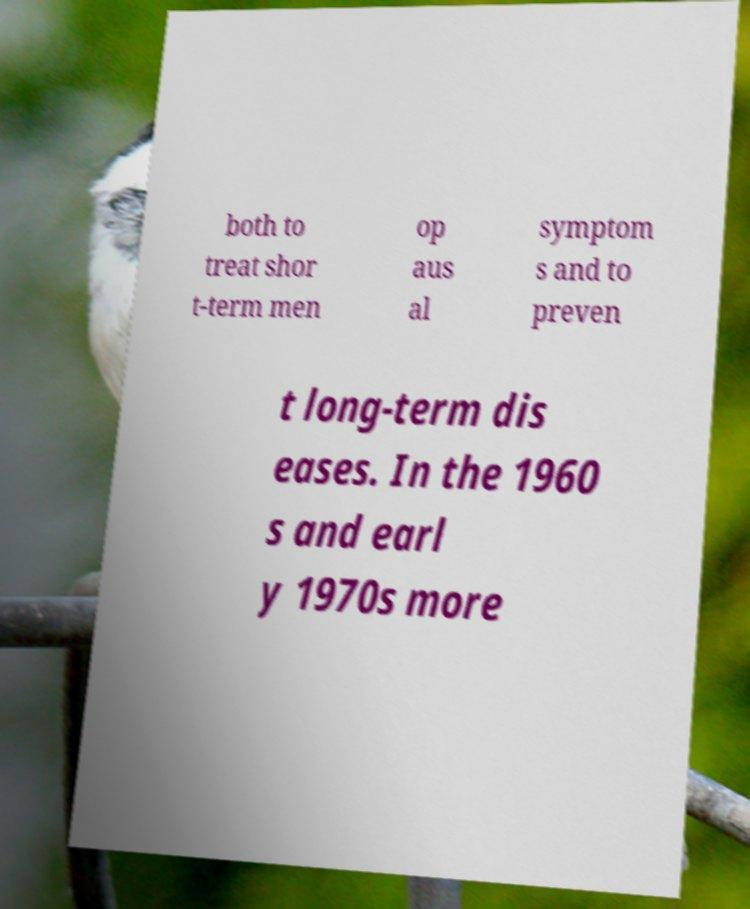Could you extract and type out the text from this image? both to treat shor t-term men op aus al symptom s and to preven t long-term dis eases. In the 1960 s and earl y 1970s more 